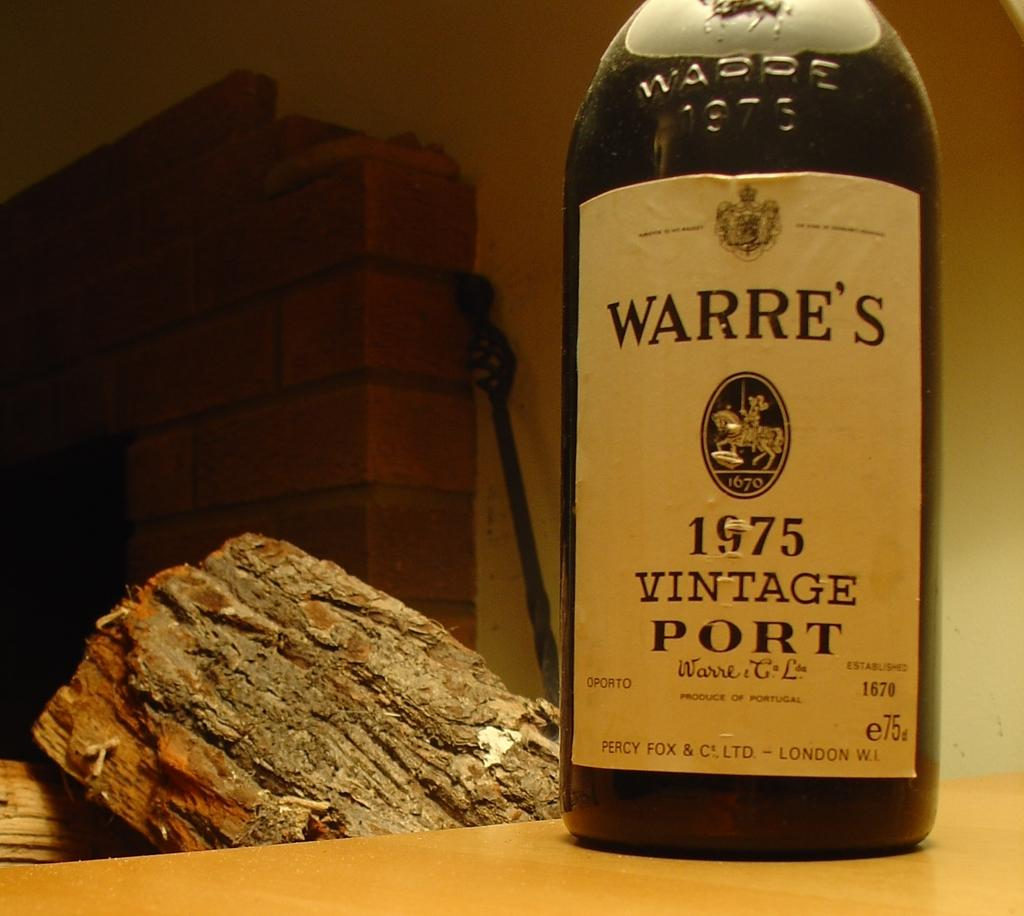<image>
Present a compact description of the photo's key features. A bottle of Warre's 1975 Vintage Port beside a piece of wood. 